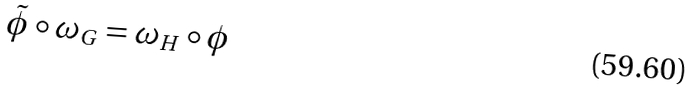Convert formula to latex. <formula><loc_0><loc_0><loc_500><loc_500>\tilde { \phi } \circ \omega _ { G } = \omega _ { H } \circ \phi</formula> 